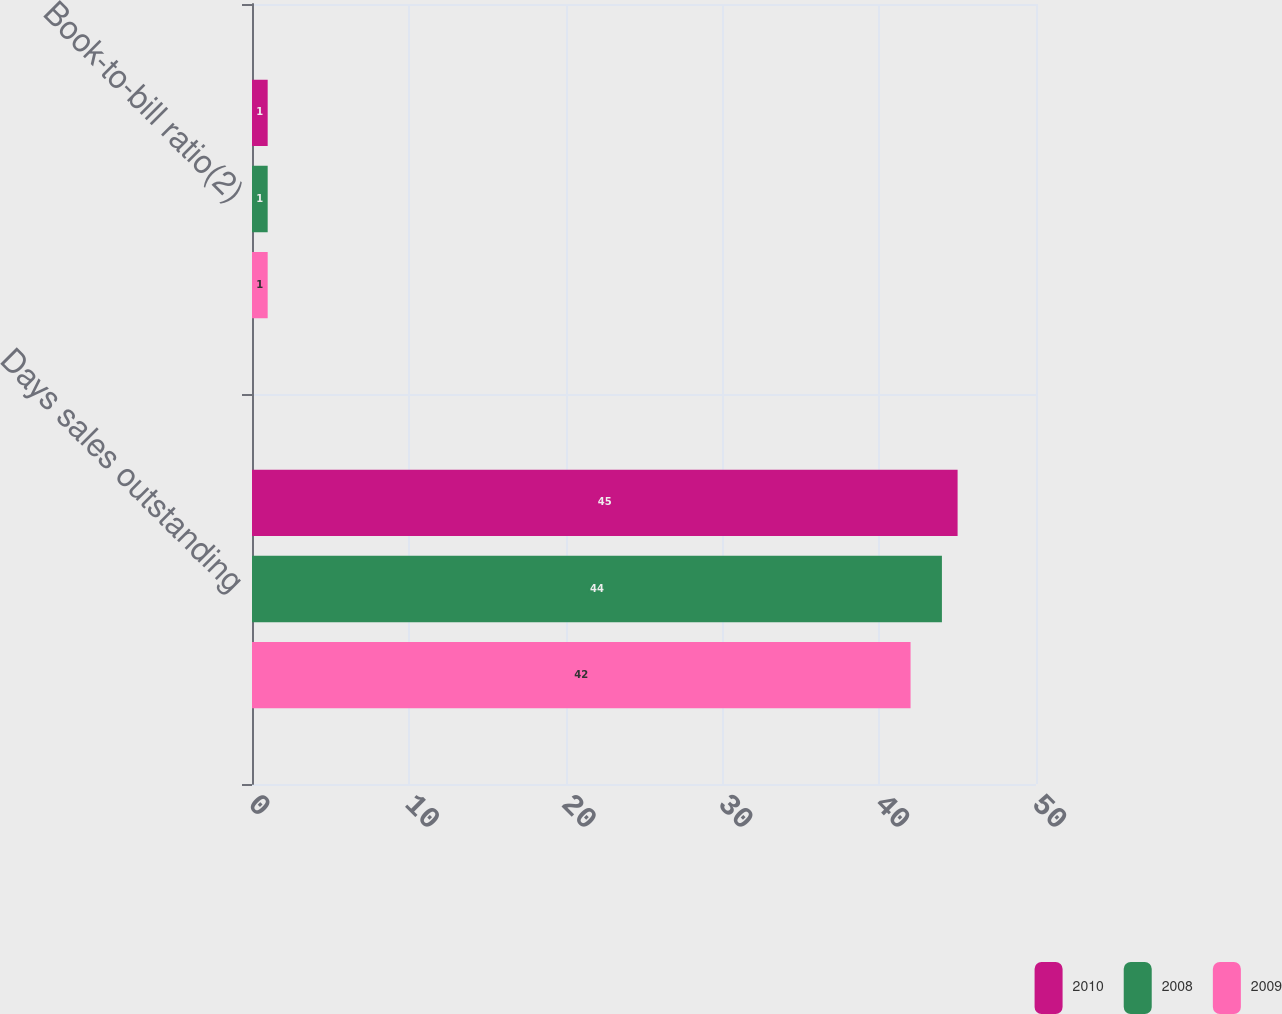Convert chart to OTSL. <chart><loc_0><loc_0><loc_500><loc_500><stacked_bar_chart><ecel><fcel>Days sales outstanding<fcel>Book-to-bill ratio(2)<nl><fcel>2010<fcel>45<fcel>1<nl><fcel>2008<fcel>44<fcel>1<nl><fcel>2009<fcel>42<fcel>1<nl></chart> 